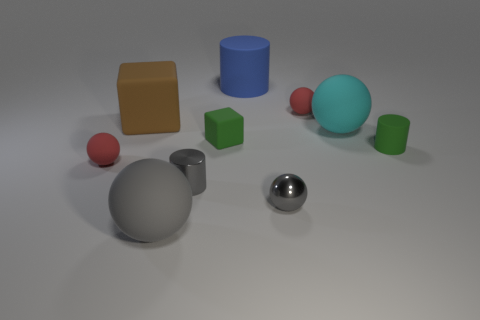Is the number of small metal things behind the gray metallic sphere greater than the number of large blue cylinders that are behind the blue matte cylinder?
Your answer should be compact. Yes. There is a gray matte ball on the left side of the small shiny sphere; does it have the same size as the red matte sphere that is behind the brown object?
Offer a very short reply. No. The large brown object has what shape?
Provide a succinct answer. Cube. There is a cylinder that is the same color as the shiny sphere; what is its size?
Provide a succinct answer. Small. There is a big cylinder that is the same material as the big brown cube; what color is it?
Keep it short and to the point. Blue. Do the brown object and the gray cylinder that is in front of the blue cylinder have the same material?
Make the answer very short. No. The big block has what color?
Your response must be concise. Brown. What is the size of the green block that is the same material as the big blue object?
Make the answer very short. Small. There is a small green cylinder that is behind the small red ball that is in front of the cyan rubber sphere; what number of red matte spheres are in front of it?
Give a very brief answer. 1. There is a small metal sphere; does it have the same color as the tiny metallic thing to the left of the green block?
Make the answer very short. Yes. 